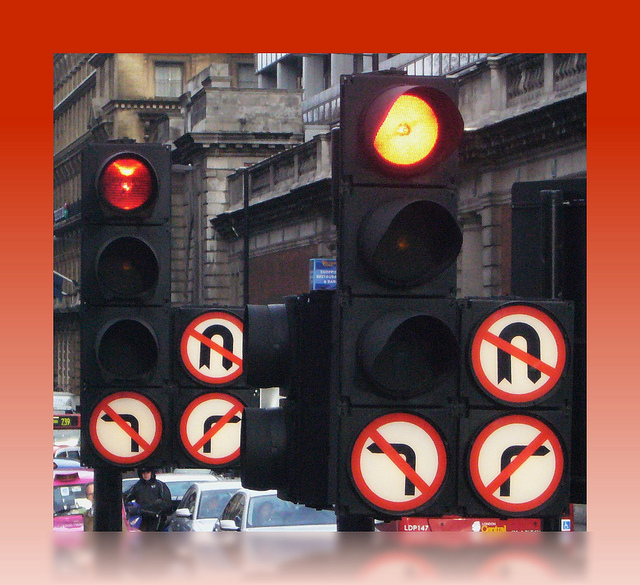<image>Why is it illegal to make U-turns in certain times of day? It is unknown why it is illegal to make U-turns at certain times of the day. It could be due to laws or traffic reasons. Why is it illegal to make U-turns in certain times of day? I don't know why it is illegal to make U-turns in certain times of day. It can be because it disrupts traffic flow, there is too much traffic, or it is against the law. 